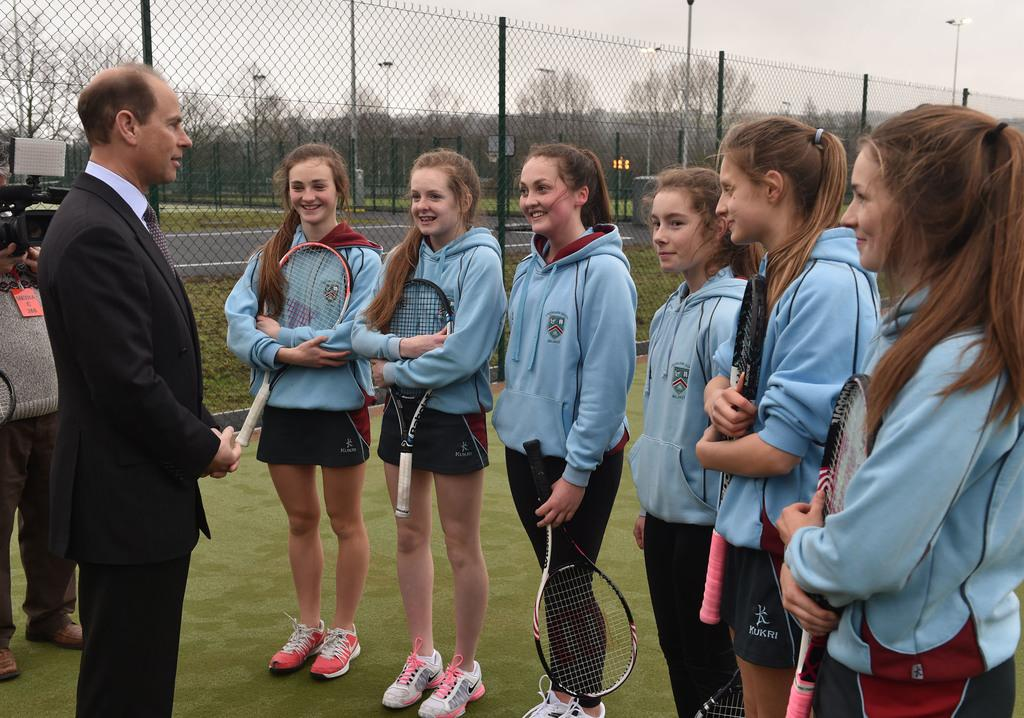How many people are in the image? There are people in the image, but the exact number is not specified. What are the people holding in the image? The people are standing and holding tennis rackets in the image. What is located behind the people? There is fencing behind the people, with poles and trees visible behind the fencing. What can be seen in the background of the image? The sky is visible in the background of the image. What type of friction is present between the tennis rackets and the ground in the image? There is no mention of friction or any interaction between the tennis rackets and the ground in the image. --- Facts: 1. There is a person in the image. 12. The person is wearing a hat. 13. The person is holding a book. 14. There is a bookshelf in the background. 15. The bookshelf is filled with books. Absurd Topics: elephant, parrot, giraffe Conversation: Who or what is present in the image? There is a person in the image. What is the person wearing in the image? The person is wearing a hat in the image. What is the person holding in the image? The person is holding a book in the image. What can be seen in the background of the image? There is a bookshelf in the background of the image. How are the bookshelf filled in the image? The bookshelf is filled with books in the image. Reasoning: Let's think step by step in order to produce the conversation. We start by identifying the main subject of the image, which is the person. Next, we describe specific features of the person, such as the hat and the book they are holding. Then, we observe the background of the image, noting the presence of the bookshelf. Finally, we describe the state of the bookshelf, mentioning that it is filled with books. Absurd Question/Answer: What type of elephant can be seen interacting with the parrot in the image? There is no mention of an elephant or a parrot in the image. --- Facts: 11. There is a person in the image. 12. The person is sitting on a chair. 13. The person is holding a cup of coffee. 14. There is a table in front of the person. 15. The table has a plate of cookies on it. Absurd Topics: lion, tiger, cheetah Conversation: Who or what is present in the image? There is a person in the image. What is the person doing in the image? The person is sitting on a chair in the image. 